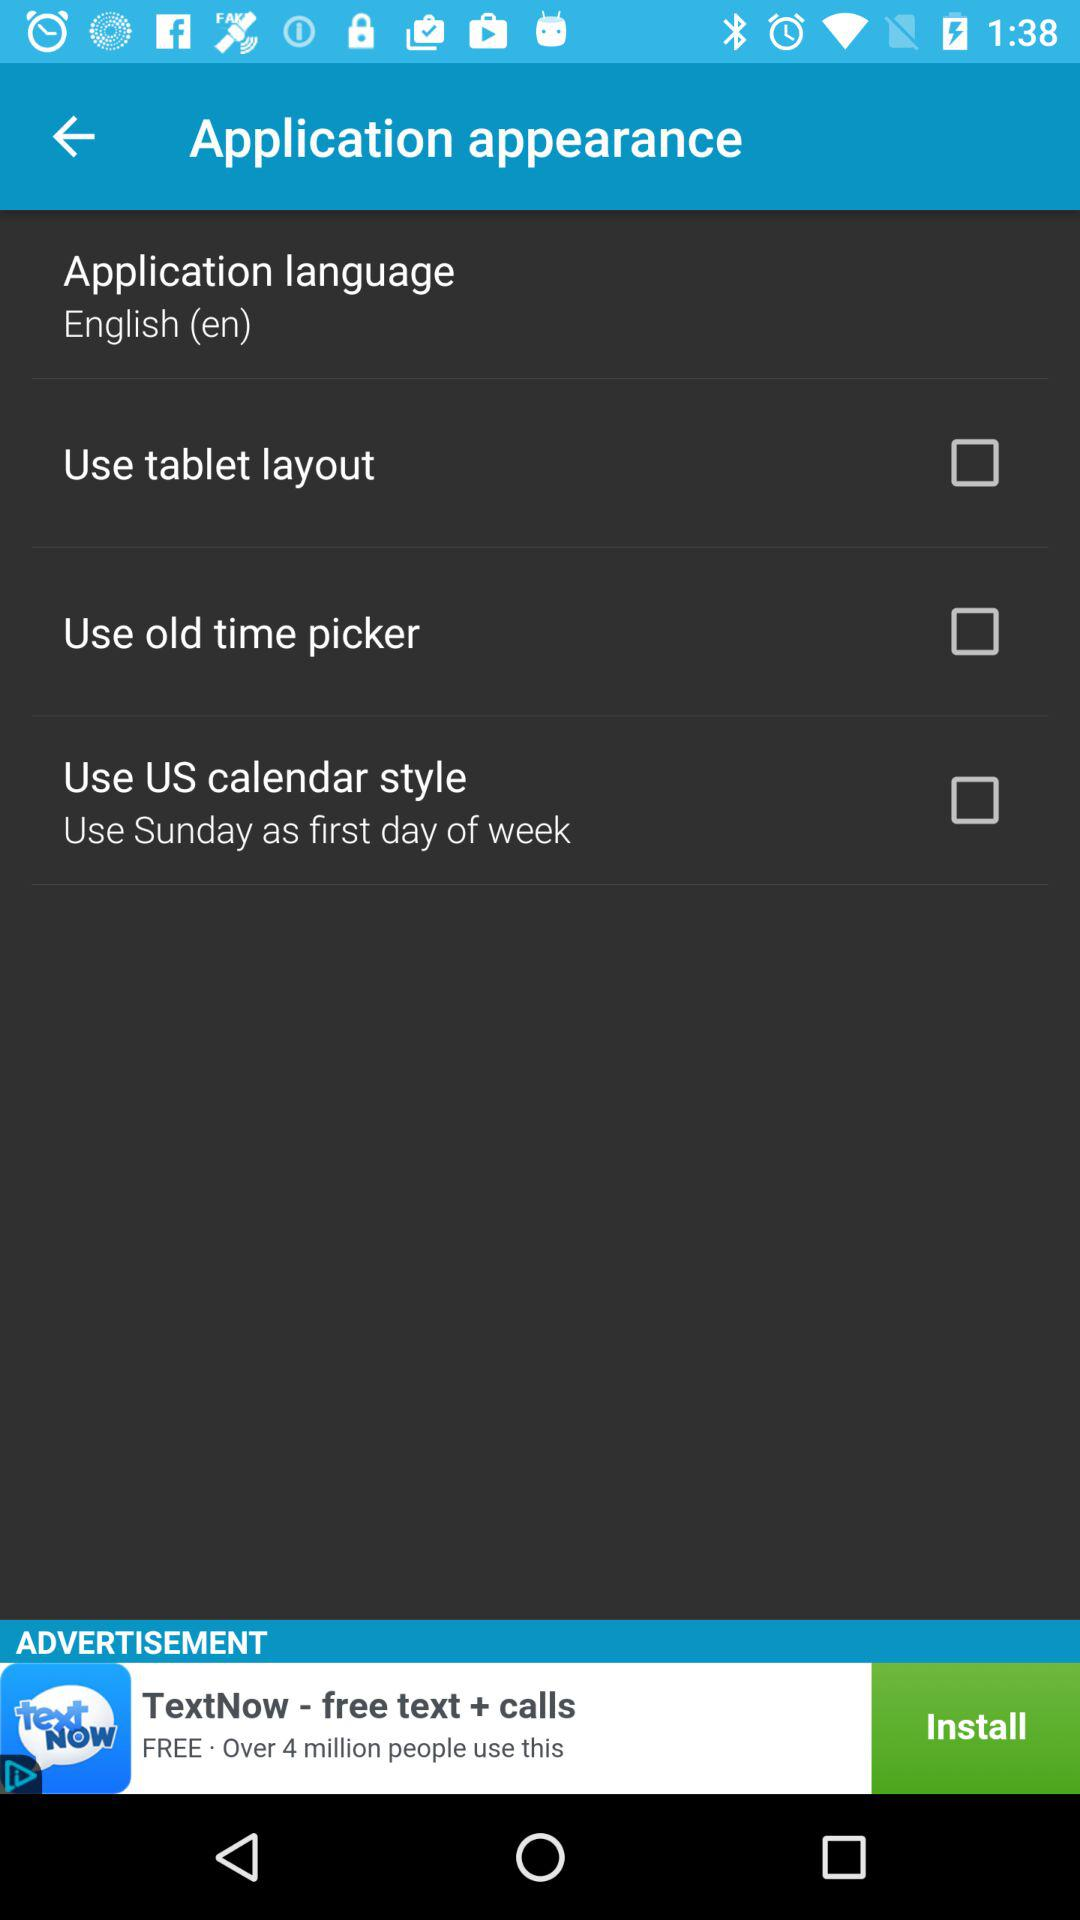What is the status of "Use tablet layout"? The status of "Use tablet layout" is "off". 